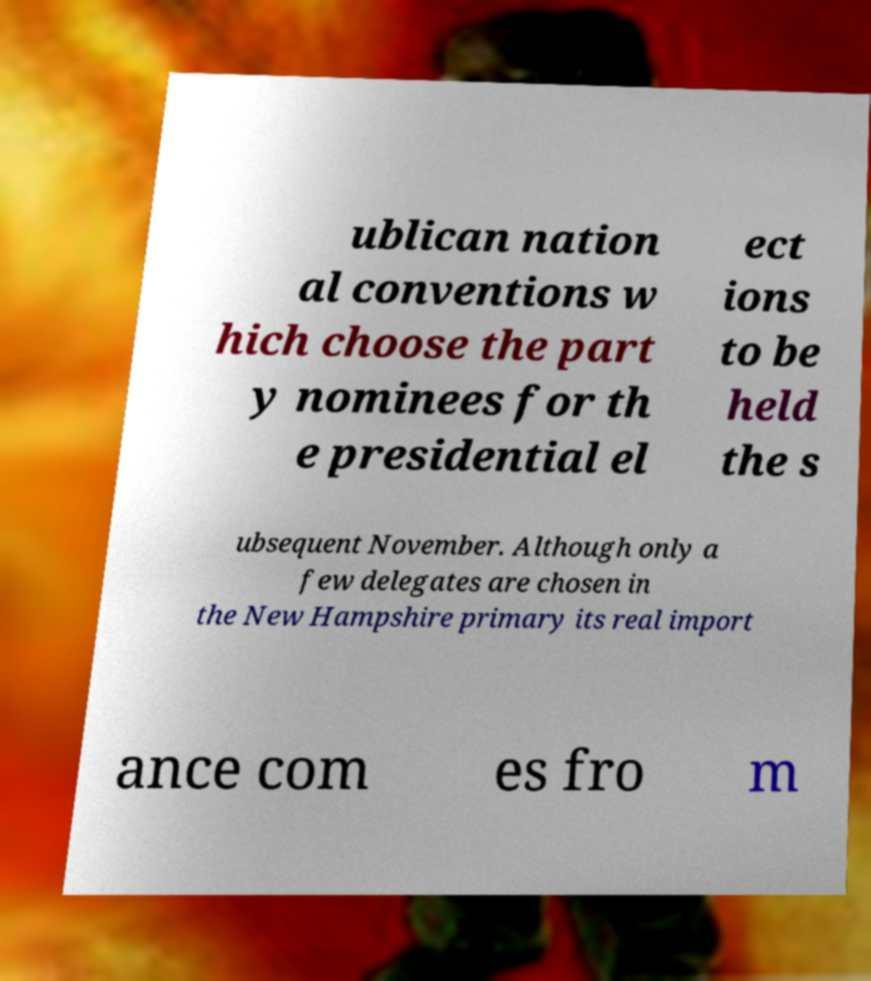Could you assist in decoding the text presented in this image and type it out clearly? ublican nation al conventions w hich choose the part y nominees for th e presidential el ect ions to be held the s ubsequent November. Although only a few delegates are chosen in the New Hampshire primary its real import ance com es fro m 